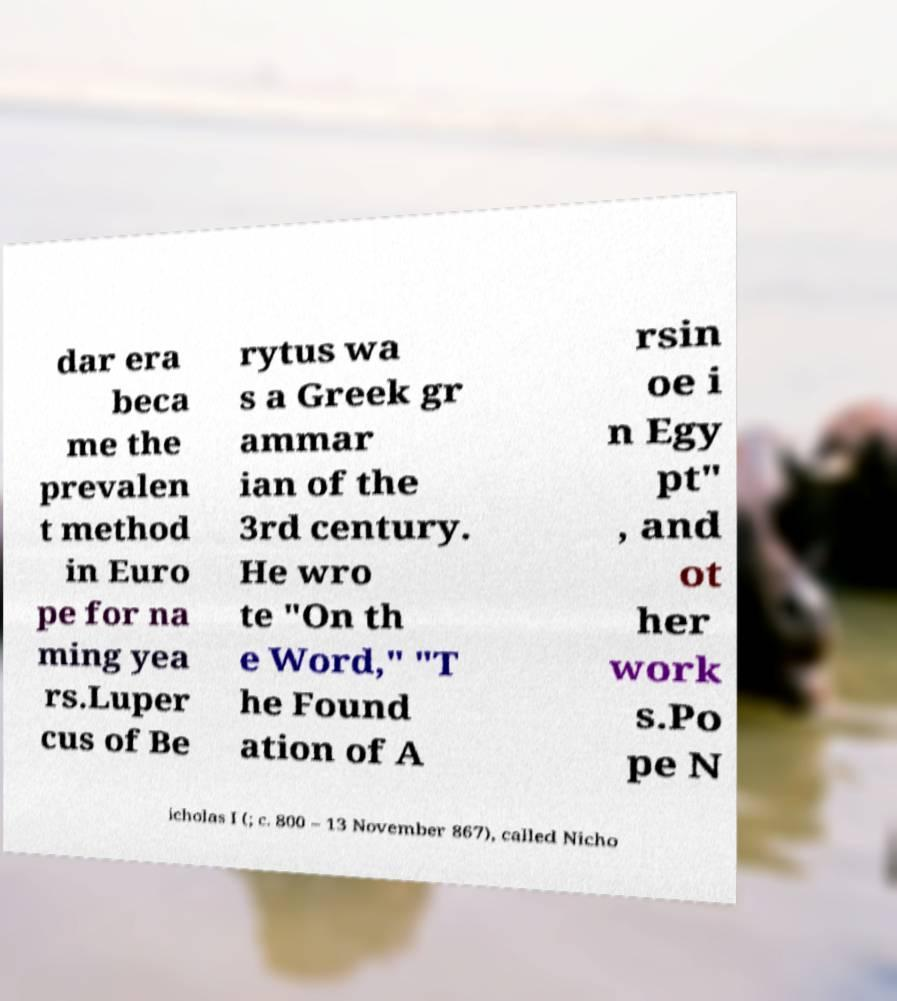Could you assist in decoding the text presented in this image and type it out clearly? dar era beca me the prevalen t method in Euro pe for na ming yea rs.Luper cus of Be rytus wa s a Greek gr ammar ian of the 3rd century. He wro te "On th e Word," "T he Found ation of A rsin oe i n Egy pt" , and ot her work s.Po pe N icholas I (; c. 800 – 13 November 867), called Nicho 